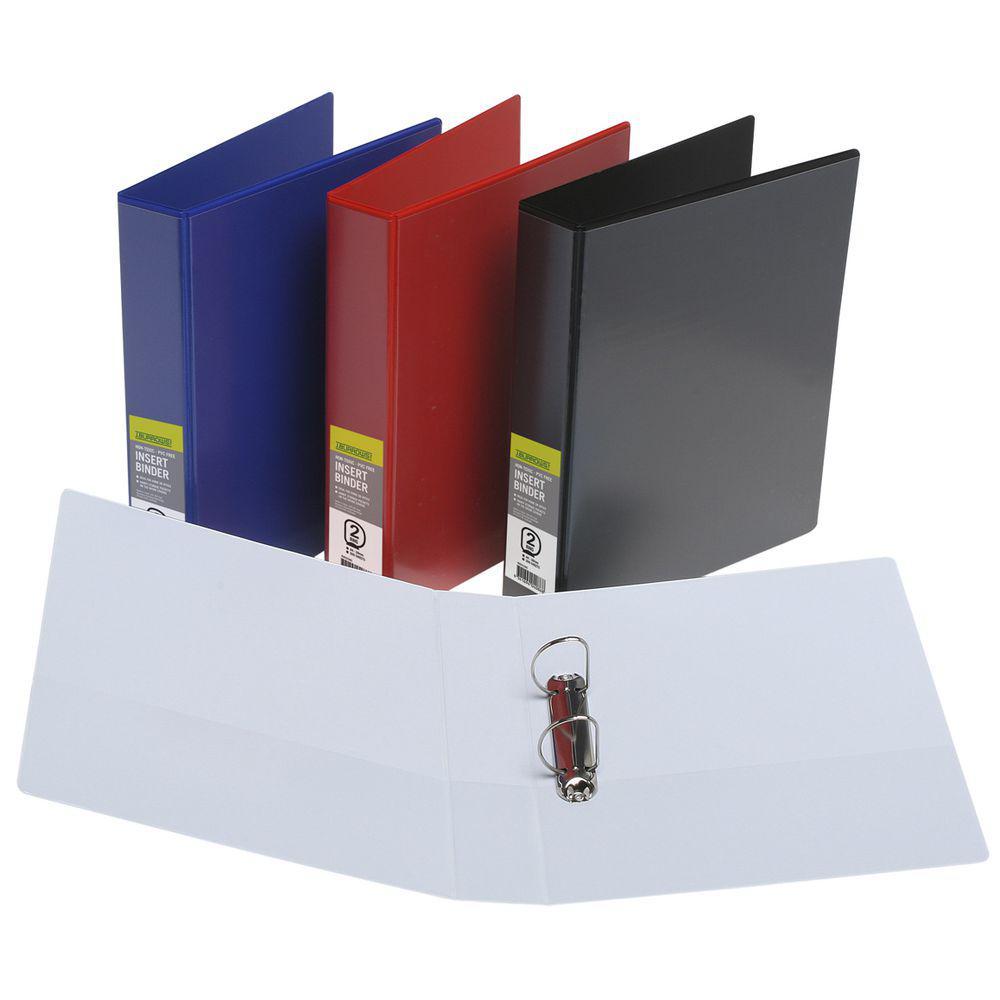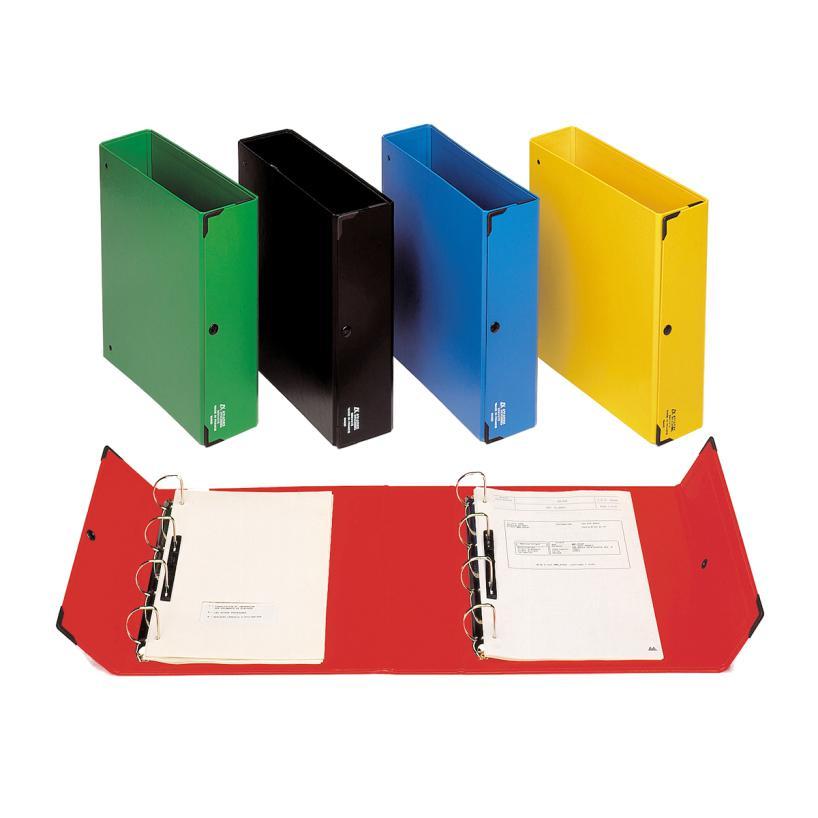The first image is the image on the left, the second image is the image on the right. Assess this claim about the two images: "An open ring binder with papers in it lies flat next to at least two upright closed binders.". Correct or not? Answer yes or no. Yes. The first image is the image on the left, the second image is the image on the right. For the images displayed, is the sentence "A binder is on top of a desk." factually correct? Answer yes or no. No. 